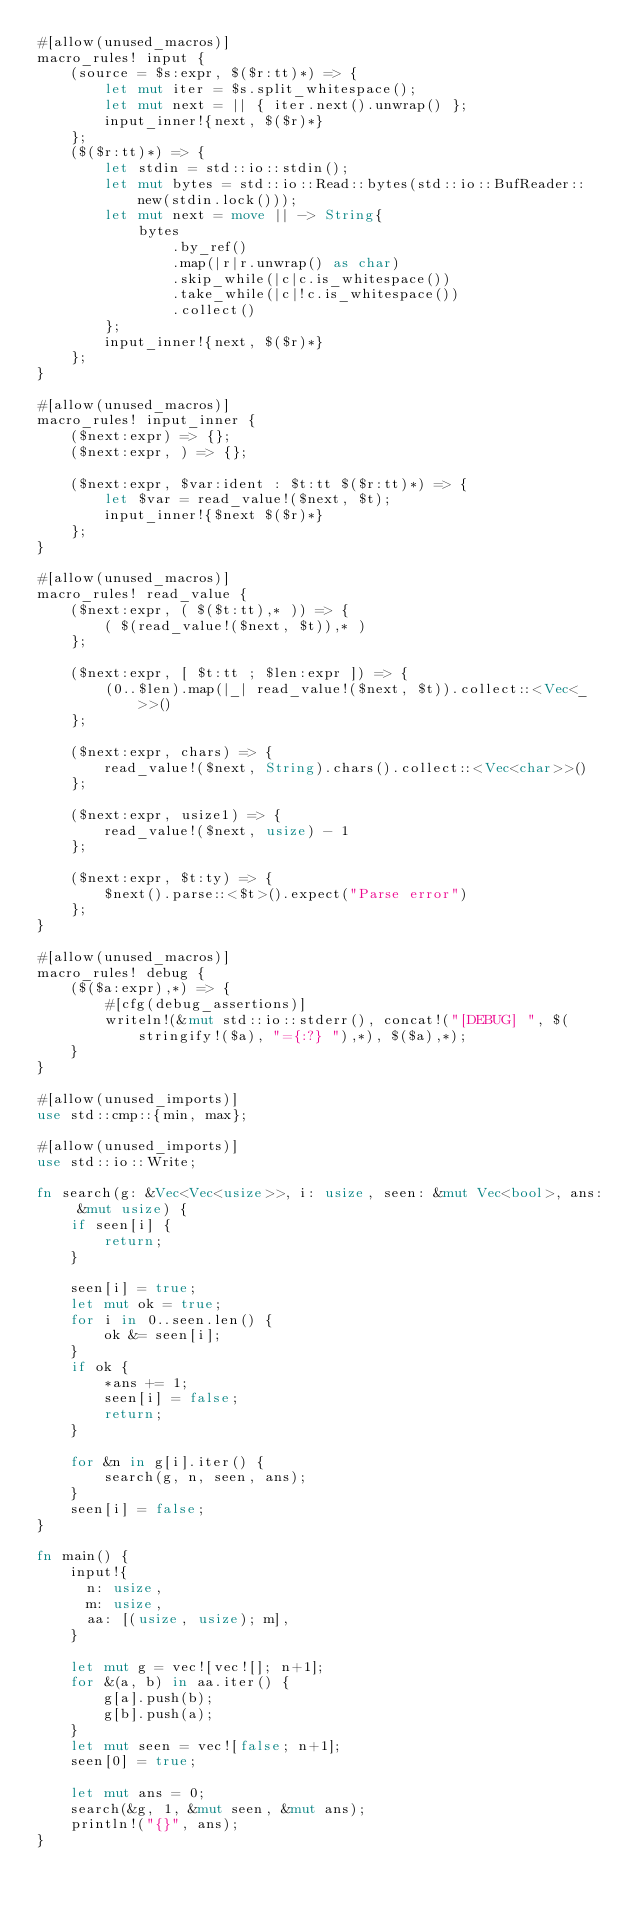Convert code to text. <code><loc_0><loc_0><loc_500><loc_500><_Rust_>#[allow(unused_macros)]
macro_rules! input {
    (source = $s:expr, $($r:tt)*) => {
        let mut iter = $s.split_whitespace();
        let mut next = || { iter.next().unwrap() };
        input_inner!{next, $($r)*}
    };
    ($($r:tt)*) => {
        let stdin = std::io::stdin();
        let mut bytes = std::io::Read::bytes(std::io::BufReader::new(stdin.lock()));
        let mut next = move || -> String{
            bytes
                .by_ref()
                .map(|r|r.unwrap() as char)
                .skip_while(|c|c.is_whitespace())
                .take_while(|c|!c.is_whitespace())
                .collect()
        };
        input_inner!{next, $($r)*}
    };
}

#[allow(unused_macros)]
macro_rules! input_inner {
    ($next:expr) => {};
    ($next:expr, ) => {};

    ($next:expr, $var:ident : $t:tt $($r:tt)*) => {
        let $var = read_value!($next, $t);
        input_inner!{$next $($r)*}
    };
}

#[allow(unused_macros)]
macro_rules! read_value {
    ($next:expr, ( $($t:tt),* )) => {
        ( $(read_value!($next, $t)),* )
    };

    ($next:expr, [ $t:tt ; $len:expr ]) => {
        (0..$len).map(|_| read_value!($next, $t)).collect::<Vec<_>>()
    };

    ($next:expr, chars) => {
        read_value!($next, String).chars().collect::<Vec<char>>()
    };

    ($next:expr, usize1) => {
        read_value!($next, usize) - 1
    };

    ($next:expr, $t:ty) => {
        $next().parse::<$t>().expect("Parse error")
    };
}

#[allow(unused_macros)]
macro_rules! debug {
    ($($a:expr),*) => {
        #[cfg(debug_assertions)]
        writeln!(&mut std::io::stderr(), concat!("[DEBUG] ", $(stringify!($a), "={:?} "),*), $($a),*);
    }
}

#[allow(unused_imports)]
use std::cmp::{min, max};

#[allow(unused_imports)]
use std::io::Write;

fn search(g: &Vec<Vec<usize>>, i: usize, seen: &mut Vec<bool>, ans: &mut usize) {
    if seen[i] {
        return;
    }

    seen[i] = true;
    let mut ok = true;
    for i in 0..seen.len() {
        ok &= seen[i];
    }
    if ok {
        *ans += 1;
        seen[i] = false;
        return;
    }

    for &n in g[i].iter() {
        search(g, n, seen, ans);
    }
    seen[i] = false;
}

fn main() {
    input!{
      n: usize,
      m: usize,
      aa: [(usize, usize); m],
    }

    let mut g = vec![vec![]; n+1];
    for &(a, b) in aa.iter() {
        g[a].push(b);
        g[b].push(a);
    }
    let mut seen = vec![false; n+1];
    seen[0] = true;

    let mut ans = 0;
    search(&g, 1, &mut seen, &mut ans);
    println!("{}", ans);
}
</code> 